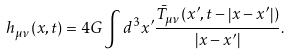Convert formula to latex. <formula><loc_0><loc_0><loc_500><loc_500>h _ { \mu \nu } ( x , t ) = 4 G \int { d ^ { 3 } x ^ { \prime } \frac { \bar { T } _ { \mu \nu } ( x ^ { \prime } , t - \left | x - x ^ { \prime } \right | ) } { \left | x - x ^ { \prime } \right | } } .</formula> 